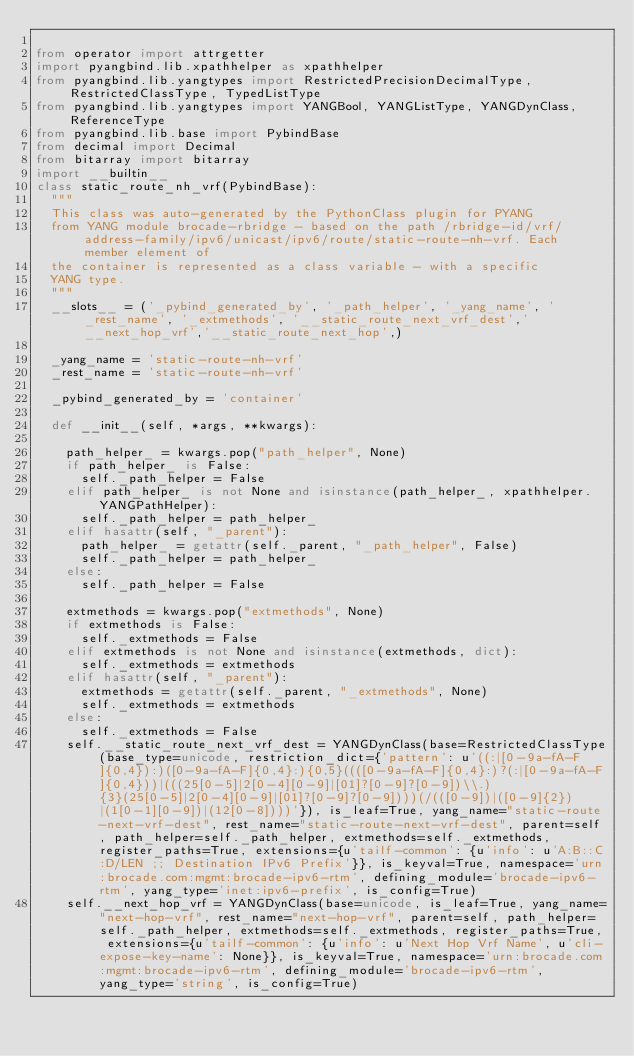<code> <loc_0><loc_0><loc_500><loc_500><_Python_>
from operator import attrgetter
import pyangbind.lib.xpathhelper as xpathhelper
from pyangbind.lib.yangtypes import RestrictedPrecisionDecimalType, RestrictedClassType, TypedListType
from pyangbind.lib.yangtypes import YANGBool, YANGListType, YANGDynClass, ReferenceType
from pyangbind.lib.base import PybindBase
from decimal import Decimal
from bitarray import bitarray
import __builtin__
class static_route_nh_vrf(PybindBase):
  """
  This class was auto-generated by the PythonClass plugin for PYANG
  from YANG module brocade-rbridge - based on the path /rbridge-id/vrf/address-family/ipv6/unicast/ipv6/route/static-route-nh-vrf. Each member element of
  the container is represented as a class variable - with a specific
  YANG type.
  """
  __slots__ = ('_pybind_generated_by', '_path_helper', '_yang_name', '_rest_name', '_extmethods', '__static_route_next_vrf_dest','__next_hop_vrf','__static_route_next_hop',)

  _yang_name = 'static-route-nh-vrf'
  _rest_name = 'static-route-nh-vrf'

  _pybind_generated_by = 'container'

  def __init__(self, *args, **kwargs):

    path_helper_ = kwargs.pop("path_helper", None)
    if path_helper_ is False:
      self._path_helper = False
    elif path_helper_ is not None and isinstance(path_helper_, xpathhelper.YANGPathHelper):
      self._path_helper = path_helper_
    elif hasattr(self, "_parent"):
      path_helper_ = getattr(self._parent, "_path_helper", False)
      self._path_helper = path_helper_
    else:
      self._path_helper = False

    extmethods = kwargs.pop("extmethods", None)
    if extmethods is False:
      self._extmethods = False
    elif extmethods is not None and isinstance(extmethods, dict):
      self._extmethods = extmethods
    elif hasattr(self, "_parent"):
      extmethods = getattr(self._parent, "_extmethods", None)
      self._extmethods = extmethods
    else:
      self._extmethods = False
    self.__static_route_next_vrf_dest = YANGDynClass(base=RestrictedClassType(base_type=unicode, restriction_dict={'pattern': u'((:|[0-9a-fA-F]{0,4}):)([0-9a-fA-F]{0,4}:){0,5}((([0-9a-fA-F]{0,4}:)?(:|[0-9a-fA-F]{0,4}))|(((25[0-5]|2[0-4][0-9]|[01]?[0-9]?[0-9])\\.){3}(25[0-5]|2[0-4][0-9]|[01]?[0-9]?[0-9])))(/(([0-9])|([0-9]{2})|(1[0-1][0-9])|(12[0-8])))'}), is_leaf=True, yang_name="static-route-next-vrf-dest", rest_name="static-route-next-vrf-dest", parent=self, path_helper=self._path_helper, extmethods=self._extmethods, register_paths=True, extensions={u'tailf-common': {u'info': u'A:B::C:D/LEN ;; Destination IPv6 Prefix'}}, is_keyval=True, namespace='urn:brocade.com:mgmt:brocade-ipv6-rtm', defining_module='brocade-ipv6-rtm', yang_type='inet:ipv6-prefix', is_config=True)
    self.__next_hop_vrf = YANGDynClass(base=unicode, is_leaf=True, yang_name="next-hop-vrf", rest_name="next-hop-vrf", parent=self, path_helper=self._path_helper, extmethods=self._extmethods, register_paths=True, extensions={u'tailf-common': {u'info': u'Next Hop Vrf Name', u'cli-expose-key-name': None}}, is_keyval=True, namespace='urn:brocade.com:mgmt:brocade-ipv6-rtm', defining_module='brocade-ipv6-rtm', yang_type='string', is_config=True)</code> 